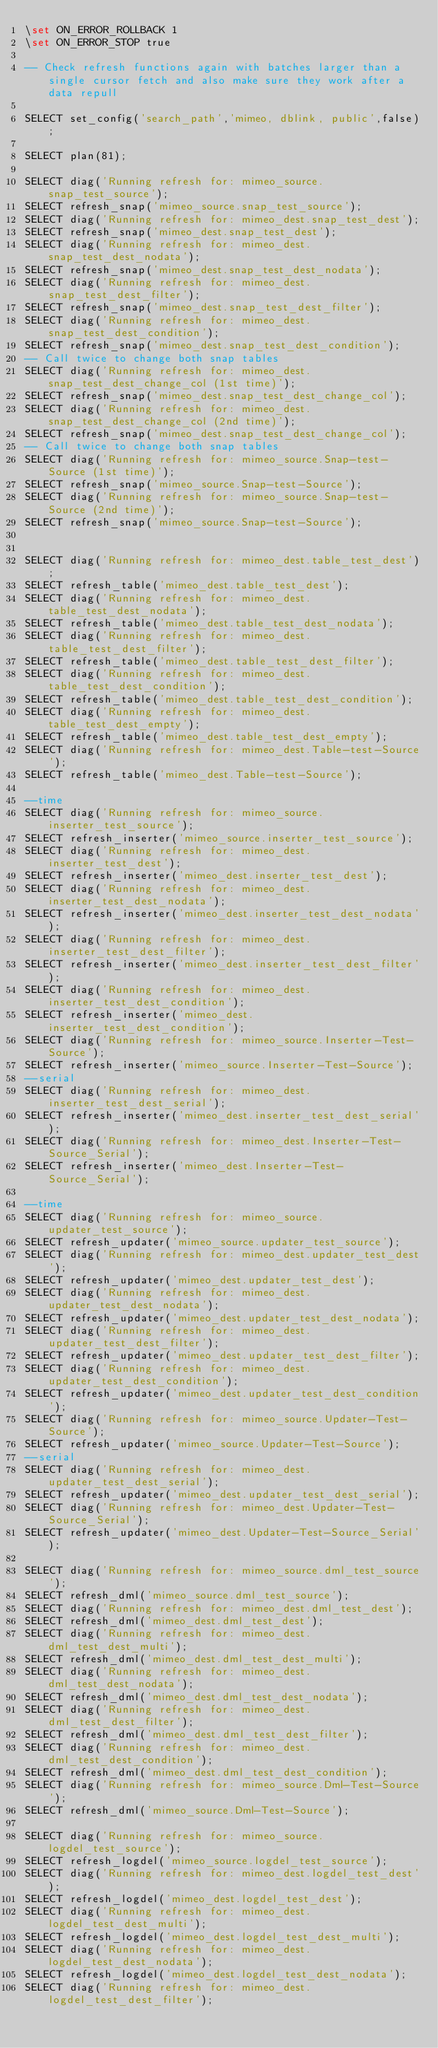<code> <loc_0><loc_0><loc_500><loc_500><_SQL_>\set ON_ERROR_ROLLBACK 1
\set ON_ERROR_STOP true

-- Check refresh functions again with batches larger than a single cursor fetch and also make sure they work after a data repull

SELECT set_config('search_path','mimeo, dblink, public',false);

SELECT plan(81);

SELECT diag('Running refresh for: mimeo_source.snap_test_source');
SELECT refresh_snap('mimeo_source.snap_test_source');
SELECT diag('Running refresh for: mimeo_dest.snap_test_dest');
SELECT refresh_snap('mimeo_dest.snap_test_dest');
SELECT diag('Running refresh for: mimeo_dest.snap_test_dest_nodata');
SELECT refresh_snap('mimeo_dest.snap_test_dest_nodata');
SELECT diag('Running refresh for: mimeo_dest.snap_test_dest_filter');
SELECT refresh_snap('mimeo_dest.snap_test_dest_filter');
SELECT diag('Running refresh for: mimeo_dest.snap_test_dest_condition');
SELECT refresh_snap('mimeo_dest.snap_test_dest_condition');
-- Call twice to change both snap tables
SELECT diag('Running refresh for: mimeo_dest.snap_test_dest_change_col (1st time)');
SELECT refresh_snap('mimeo_dest.snap_test_dest_change_col');
SELECT diag('Running refresh for: mimeo_dest.snap_test_dest_change_col (2nd time)');
SELECT refresh_snap('mimeo_dest.snap_test_dest_change_col');
-- Call twice to change both snap tables
SELECT diag('Running refresh for: mimeo_source.Snap-test-Source (1st time)');
SELECT refresh_snap('mimeo_source.Snap-test-Source');
SELECT diag('Running refresh for: mimeo_source.Snap-test-Source (2nd time)');
SELECT refresh_snap('mimeo_source.Snap-test-Source');


SELECT diag('Running refresh for: mimeo_dest.table_test_dest');
SELECT refresh_table('mimeo_dest.table_test_dest');
SELECT diag('Running refresh for: mimeo_dest.table_test_dest_nodata');
SELECT refresh_table('mimeo_dest.table_test_dest_nodata');
SELECT diag('Running refresh for: mimeo_dest.table_test_dest_filter');
SELECT refresh_table('mimeo_dest.table_test_dest_filter');
SELECT diag('Running refresh for: mimeo_dest.table_test_dest_condition');
SELECT refresh_table('mimeo_dest.table_test_dest_condition');
SELECT diag('Running refresh for: mimeo_dest.table_test_dest_empty');
SELECT refresh_table('mimeo_dest.table_test_dest_empty');
SELECT diag('Running refresh for: mimeo_dest.Table-test-Source');
SELECT refresh_table('mimeo_dest.Table-test-Source');

--time
SELECT diag('Running refresh for: mimeo_source.inserter_test_source');
SELECT refresh_inserter('mimeo_source.inserter_test_source');
SELECT diag('Running refresh for: mimeo_dest.inserter_test_dest');
SELECT refresh_inserter('mimeo_dest.inserter_test_dest');
SELECT diag('Running refresh for: mimeo_dest.inserter_test_dest_nodata');
SELECT refresh_inserter('mimeo_dest.inserter_test_dest_nodata');
SELECT diag('Running refresh for: mimeo_dest.inserter_test_dest_filter');
SELECT refresh_inserter('mimeo_dest.inserter_test_dest_filter');
SELECT diag('Running refresh for: mimeo_dest.inserter_test_dest_condition');
SELECT refresh_inserter('mimeo_dest.inserter_test_dest_condition');
SELECT diag('Running refresh for: mimeo_source.Inserter-Test-Source');
SELECT refresh_inserter('mimeo_source.Inserter-Test-Source');
--serial
SELECT diag('Running refresh for: mimeo_dest.inserter_test_dest_serial');
SELECT refresh_inserter('mimeo_dest.inserter_test_dest_serial');
SELECT diag('Running refresh for: mimeo_dest.Inserter-Test-Source_Serial');
SELECT refresh_inserter('mimeo_dest.Inserter-Test-Source_Serial');

--time
SELECT diag('Running refresh for: mimeo_source.updater_test_source');
SELECT refresh_updater('mimeo_source.updater_test_source');
SELECT diag('Running refresh for: mimeo_dest.updater_test_dest');
SELECT refresh_updater('mimeo_dest.updater_test_dest');
SELECT diag('Running refresh for: mimeo_dest.updater_test_dest_nodata');
SELECT refresh_updater('mimeo_dest.updater_test_dest_nodata');
SELECT diag('Running refresh for: mimeo_dest.updater_test_dest_filter');
SELECT refresh_updater('mimeo_dest.updater_test_dest_filter');
SELECT diag('Running refresh for: mimeo_dest.updater_test_dest_condition');
SELECT refresh_updater('mimeo_dest.updater_test_dest_condition');
SELECT diag('Running refresh for: mimeo_source.Updater-Test-Source');
SELECT refresh_updater('mimeo_source.Updater-Test-Source');
--serial
SELECT diag('Running refresh for: mimeo_dest.updater_test_dest_serial');
SELECT refresh_updater('mimeo_dest.updater_test_dest_serial');
SELECT diag('Running refresh for: mimeo_dest.Updater-Test-Source_Serial');
SELECT refresh_updater('mimeo_dest.Updater-Test-Source_Serial');

SELECT diag('Running refresh for: mimeo_source.dml_test_source');
SELECT refresh_dml('mimeo_source.dml_test_source');
SELECT diag('Running refresh for: mimeo_dest.dml_test_dest');
SELECT refresh_dml('mimeo_dest.dml_test_dest');
SELECT diag('Running refresh for: mimeo_dest.dml_test_dest_multi');
SELECT refresh_dml('mimeo_dest.dml_test_dest_multi');
SELECT diag('Running refresh for: mimeo_dest.dml_test_dest_nodata');
SELECT refresh_dml('mimeo_dest.dml_test_dest_nodata');
SELECT diag('Running refresh for: mimeo_dest.dml_test_dest_filter');
SELECT refresh_dml('mimeo_dest.dml_test_dest_filter');
SELECT diag('Running refresh for: mimeo_dest.dml_test_dest_condition');
SELECT refresh_dml('mimeo_dest.dml_test_dest_condition');
SELECT diag('Running refresh for: mimeo_source.Dml-Test-Source');
SELECT refresh_dml('mimeo_source.Dml-Test-Source');

SELECT diag('Running refresh for: mimeo_source.logdel_test_source');
SELECT refresh_logdel('mimeo_source.logdel_test_source');
SELECT diag('Running refresh for: mimeo_dest.logdel_test_dest');
SELECT refresh_logdel('mimeo_dest.logdel_test_dest');
SELECT diag('Running refresh for: mimeo_dest.logdel_test_dest_multi');
SELECT refresh_logdel('mimeo_dest.logdel_test_dest_multi');
SELECT diag('Running refresh for: mimeo_dest.logdel_test_dest_nodata');
SELECT refresh_logdel('mimeo_dest.logdel_test_dest_nodata');
SELECT diag('Running refresh for: mimeo_dest.logdel_test_dest_filter');</code> 